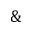<formula> <loc_0><loc_0><loc_500><loc_500>\&</formula> 